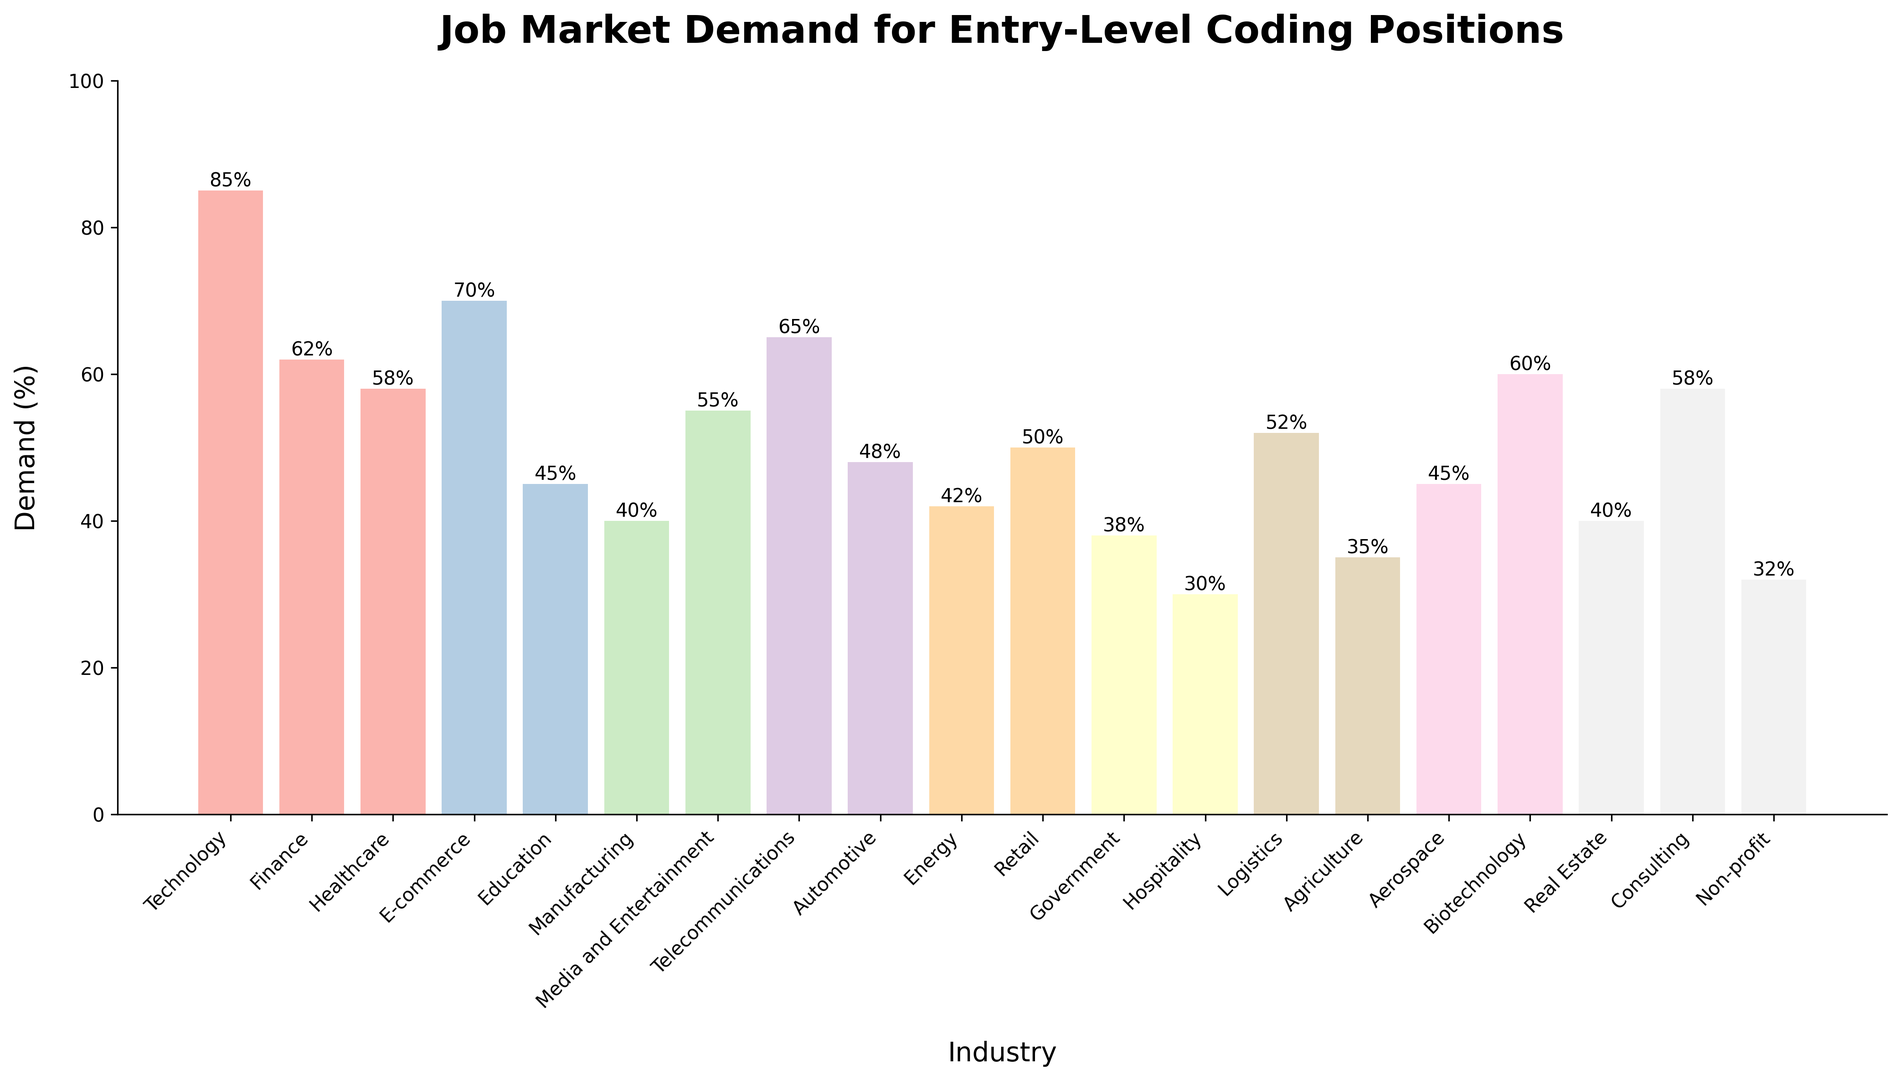Which industry has the highest demand for entry-level coding positions? The bar representing Technology is the tallest on the chart, indicating the highest demand at 85%.
Answer: Technology Which industry has the lowest demand for entry-level coding positions? The bar representing Hospitality is the shortest on the chart, indicating the lowest demand at 30%.
Answer: Hospitality What is the difference in demand between the Technology and Government industries? The demand for Technology is 85%, and for Government is 38%. The difference is 85% - 38% = 47%.
Answer: 47% Which two industries have the same demand for entry-level coding positions? Both the Education and Aerospace industries have bars that reach the same height, indicating a demand of 45%.
Answer: Education, Aerospace What is the average demand for entry-level coding positions across the Technology, Finance, and Healthcare industries? The demands are 85%, 62%, and 58%. Calculate the average by summing these values and dividing by 3: (85 + 62 + 58) / 3 = 68.33%.
Answer: 68.33% Which industry bar is in the middle in terms of height, indicating a median level of demand? With 20 industries, the median is between the 10th and 11th values when sorted. Sorting, the middle bars represent the Automotive and Retail industries at around 48-50%.
Answer: Automotive, Retail How many industries have a demand for entry-level coding positions greater than 60%? The industries with bars exceeding the 60% line are Technology, E-commerce, Telecommunications, Biotechnology, and Finance. There are 5 such industries.
Answer: 5 Which industries have lower demand than the average demand for all industries? Calculate the average across all listed industries: sum of demands (972%) divided by 20 industries gives an average of 48.6%. Industries below this average include Education, Manufacturing, Media and Entertainment, Automotive, Energy, Government, Retail, Hospitality, Logistics, Agriculture, Aerospace, Real Estate, and Non-profit.
Answer: 12 industries Compare the demand between the Healthcare and Telecommunications industries. The demand for Healthcare is 58%, and for Telecommunications is 65%. 65% is greater than 58%.
Answer: Telecommunications > Healthcare What is the cumulative demand percentage for the top three industries? The demands for the top three industries (Technology, Telecommunications, and E-commerce) are 85%, 65%, and 70%. Summing these gives 85% + 70% + 65% = 220%.
Answer: 220% 